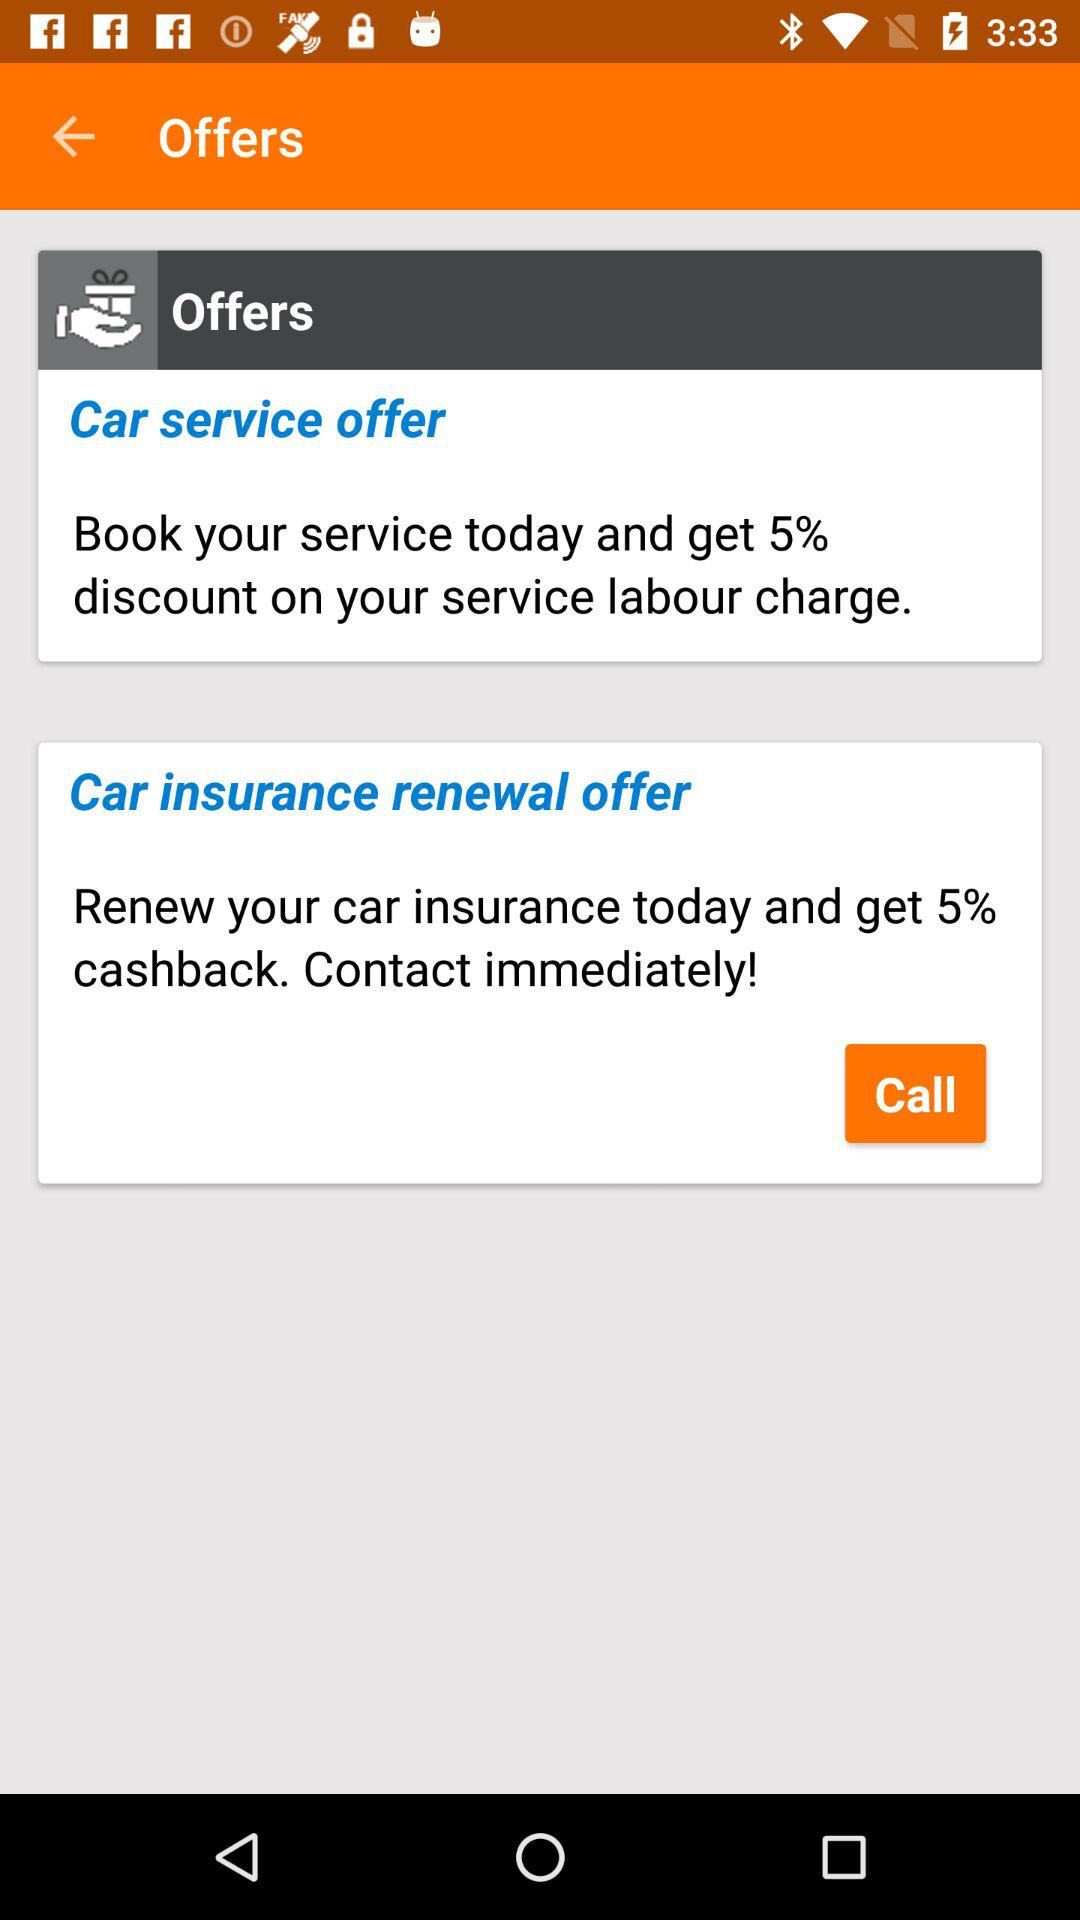How many offers are there in total?
Answer the question using a single word or phrase. 2 